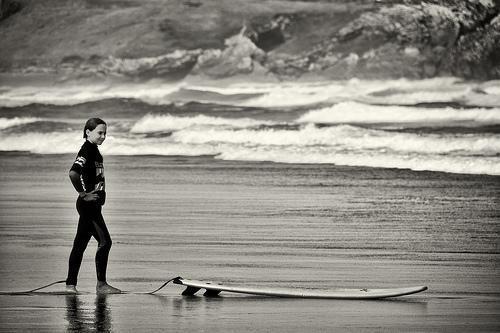How many people are in the photo?
Give a very brief answer. 1. 